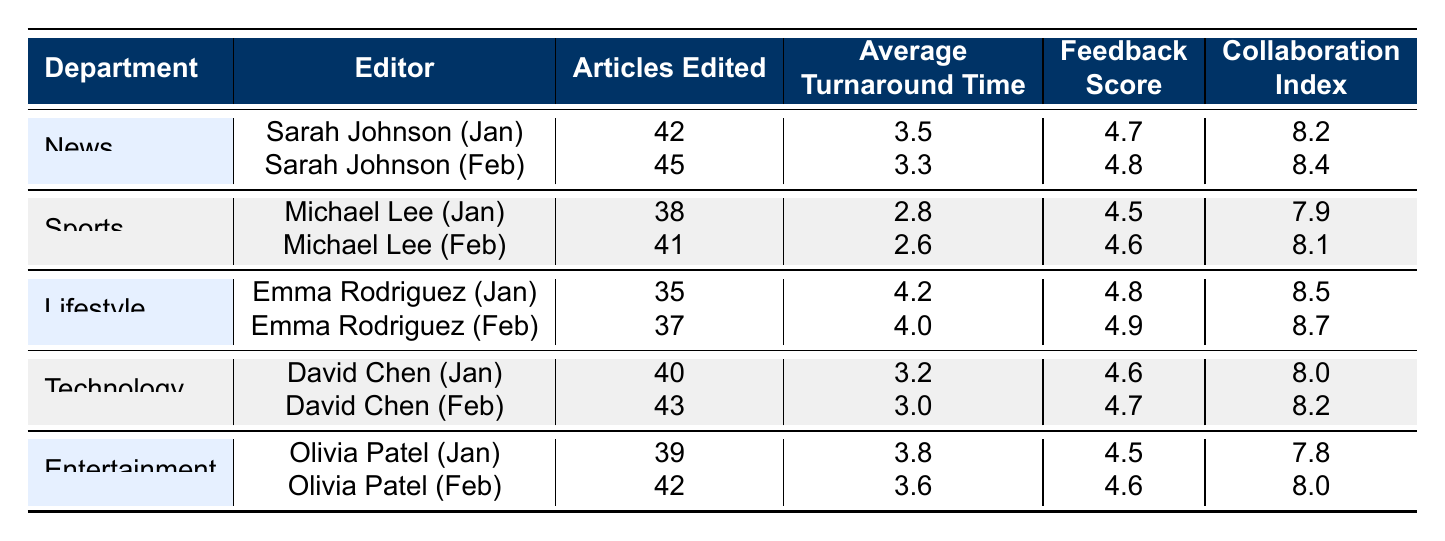What is the total number of articles edited by Sarah Johnson in January and February combined? Sarah Johnson edited 42 articles in January and 45 articles in February. To find the total, add these two values together: 42 + 45 = 87.
Answer: 87 What is the average turnaround time for articles edited by Michael Lee in January? Michael Lee's average turnaround time for January is stated directly in the table as 2.8 days.
Answer: 2.8 Which editor has the highest feedback score in February, and what is that score? In February, Sarah Johnson has a score of 4.8, Michael Lee has 4.6, Emma Rodriguez has 4.9, David Chen has 4.7, and Olivia Patel has 4.6. The highest score among these is 4.9, attributed to Emma Rodriguez.
Answer: Emma Rodriguez, 4.9 Is the average turnaround time for articles edited by David Chen in January less than 3 days? David Chen's average turnaround time for January is 3.2 days, which is greater than 3 days, so the answer is no.
Answer: No What is the combined total of articles edited by Olivia Patel over January and February? Olivia Patel edited 39 articles in January and 42 in February. To find the combined total, we add both values: 39 + 42 = 81.
Answer: 81 Which department had the editor with the highest collaboration index in January? In January, we look at the collaboration index for each editor: Sarah Johnson (8.2), Michael Lee (7.9), Emma Rodriguez (8.5), David Chen (8.0), and Olivia Patel (7.8). Emma Rodriguez has the highest collaboration index of 8.5, which is in the Lifestyle department.
Answer: Lifestyle What is the median feedback score for all editors in January? The feedback scores for January are: 4.7, 4.5, 4.8, 4.6, and 4.5. When sorted: 4.5, 4.5, 4.6, 4.7, 4.8. The median is the middle score, which is 4.6.
Answer: 4.6 Was the average turnaround time improved for Michael Lee from January to February? In January, Michael Lee's average turnaround time was 2.8 days, which improved to 2.6 days in February. Since 2.6 is less than 2.8, it indicates an improvement.
Answer: Yes How many total articles were edited by the editors in the Technology department over the two months? David Chen edited 40 articles in January and 43 in February. Adding these gives us a total of 40 + 43 = 83 articles edited in the Technology department.
Answer: 83 